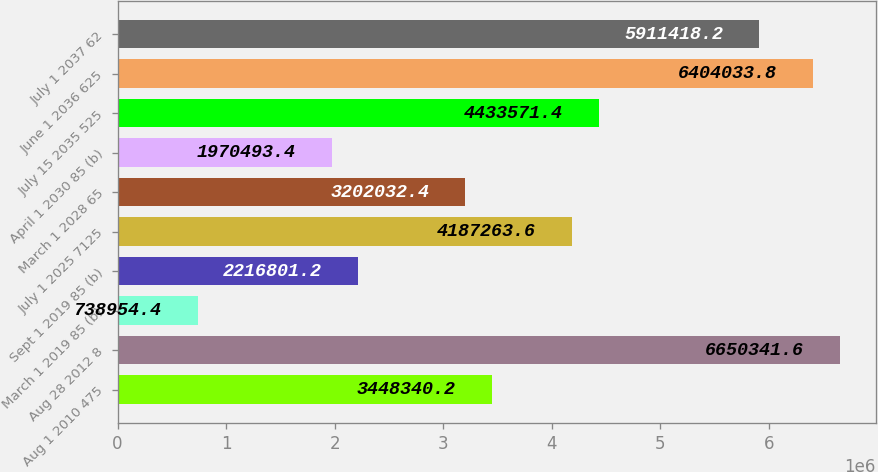Convert chart. <chart><loc_0><loc_0><loc_500><loc_500><bar_chart><fcel>Aug 1 2010 475<fcel>Aug 28 2012 8<fcel>March 1 2019 85 (b)<fcel>Sept 1 2019 85 (b)<fcel>July 1 2025 7125<fcel>March 1 2028 65<fcel>April 1 2030 85 (b)<fcel>July 15 2035 525<fcel>June 1 2036 625<fcel>July 1 2037 62<nl><fcel>3.44834e+06<fcel>6.65034e+06<fcel>738954<fcel>2.2168e+06<fcel>4.18726e+06<fcel>3.20203e+06<fcel>1.97049e+06<fcel>4.43357e+06<fcel>6.40403e+06<fcel>5.91142e+06<nl></chart> 